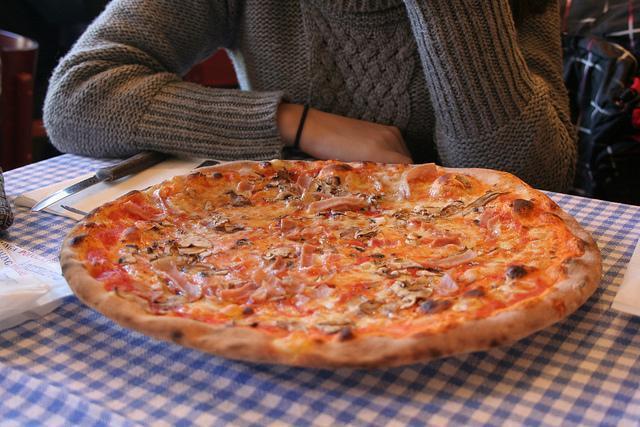How many distinct topping types are on this pizza?
Select the accurate response from the four choices given to answer the question.
Options: Two, one, four, three. Two. 